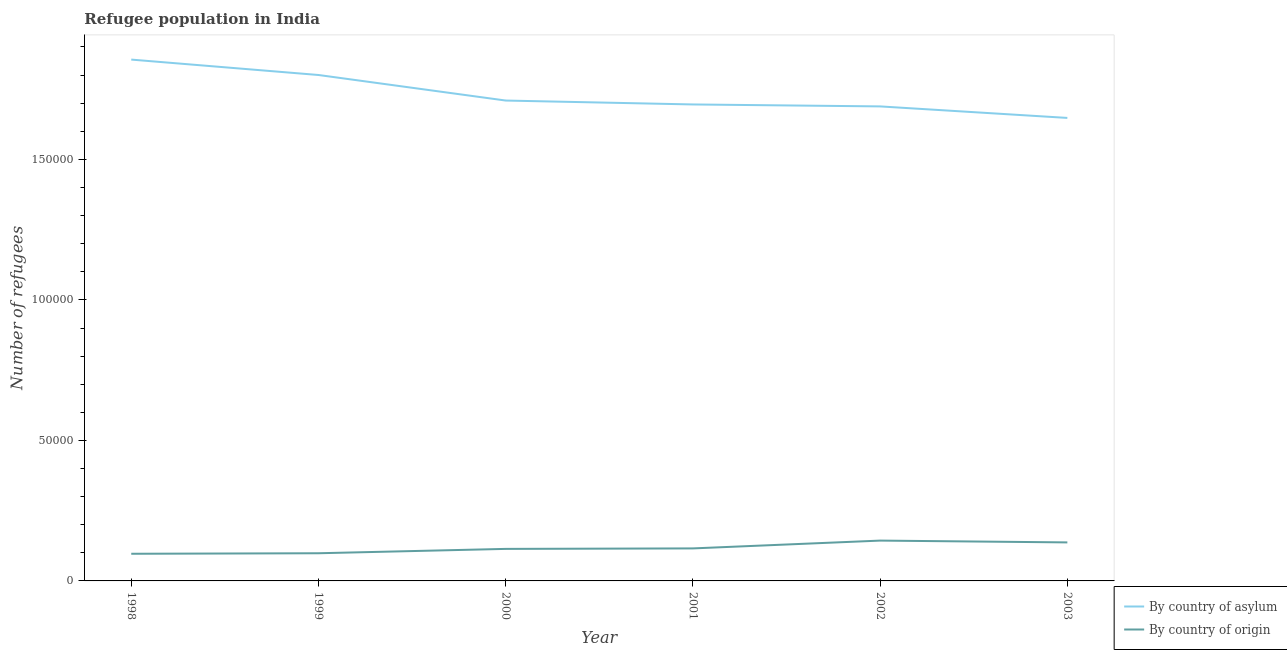Does the line corresponding to number of refugees by country of asylum intersect with the line corresponding to number of refugees by country of origin?
Offer a very short reply. No. Is the number of lines equal to the number of legend labels?
Your response must be concise. Yes. What is the number of refugees by country of origin in 2002?
Your answer should be compact. 1.43e+04. Across all years, what is the maximum number of refugees by country of origin?
Give a very brief answer. 1.43e+04. Across all years, what is the minimum number of refugees by country of origin?
Give a very brief answer. 9663. What is the total number of refugees by country of origin in the graph?
Keep it short and to the point. 7.05e+04. What is the difference between the number of refugees by country of origin in 1998 and that in 2003?
Your response must be concise. -4043. What is the difference between the number of refugees by country of origin in 2001 and the number of refugees by country of asylum in 2002?
Provide a succinct answer. -1.57e+05. What is the average number of refugees by country of asylum per year?
Your answer should be very brief. 1.73e+05. In the year 2003, what is the difference between the number of refugees by country of origin and number of refugees by country of asylum?
Keep it short and to the point. -1.51e+05. In how many years, is the number of refugees by country of origin greater than 80000?
Provide a succinct answer. 0. What is the ratio of the number of refugees by country of asylum in 1998 to that in 2000?
Offer a terse response. 1.09. Is the number of refugees by country of origin in 1998 less than that in 2001?
Provide a succinct answer. Yes. What is the difference between the highest and the second highest number of refugees by country of origin?
Your answer should be very brief. 643. What is the difference between the highest and the lowest number of refugees by country of origin?
Your response must be concise. 4686. Is the sum of the number of refugees by country of origin in 1998 and 2001 greater than the maximum number of refugees by country of asylum across all years?
Keep it short and to the point. No. Does the number of refugees by country of origin monotonically increase over the years?
Your response must be concise. No. Is the number of refugees by country of origin strictly greater than the number of refugees by country of asylum over the years?
Give a very brief answer. No. How many lines are there?
Provide a short and direct response. 2. How many years are there in the graph?
Make the answer very short. 6. What is the difference between two consecutive major ticks on the Y-axis?
Your response must be concise. 5.00e+04. Are the values on the major ticks of Y-axis written in scientific E-notation?
Your answer should be very brief. No. Does the graph contain any zero values?
Ensure brevity in your answer.  No. What is the title of the graph?
Keep it short and to the point. Refugee population in India. What is the label or title of the Y-axis?
Your response must be concise. Number of refugees. What is the Number of refugees of By country of asylum in 1998?
Your answer should be compact. 1.86e+05. What is the Number of refugees of By country of origin in 1998?
Your answer should be very brief. 9663. What is the Number of refugees in By country of asylum in 1999?
Your response must be concise. 1.80e+05. What is the Number of refugees of By country of origin in 1999?
Make the answer very short. 9845. What is the Number of refugees of By country of asylum in 2000?
Your answer should be very brief. 1.71e+05. What is the Number of refugees in By country of origin in 2000?
Ensure brevity in your answer.  1.14e+04. What is the Number of refugees in By country of asylum in 2001?
Your answer should be very brief. 1.70e+05. What is the Number of refugees of By country of origin in 2001?
Your response must be concise. 1.16e+04. What is the Number of refugees in By country of asylum in 2002?
Your response must be concise. 1.69e+05. What is the Number of refugees in By country of origin in 2002?
Provide a succinct answer. 1.43e+04. What is the Number of refugees of By country of asylum in 2003?
Ensure brevity in your answer.  1.65e+05. What is the Number of refugees in By country of origin in 2003?
Your answer should be compact. 1.37e+04. Across all years, what is the maximum Number of refugees of By country of asylum?
Your response must be concise. 1.86e+05. Across all years, what is the maximum Number of refugees of By country of origin?
Your answer should be very brief. 1.43e+04. Across all years, what is the minimum Number of refugees in By country of asylum?
Your answer should be compact. 1.65e+05. Across all years, what is the minimum Number of refugees of By country of origin?
Your response must be concise. 9663. What is the total Number of refugees in By country of asylum in the graph?
Your answer should be compact. 1.04e+06. What is the total Number of refugees in By country of origin in the graph?
Make the answer very short. 7.05e+04. What is the difference between the Number of refugees of By country of asylum in 1998 and that in 1999?
Ensure brevity in your answer.  5485. What is the difference between the Number of refugees in By country of origin in 1998 and that in 1999?
Make the answer very short. -182. What is the difference between the Number of refugees in By country of asylum in 1998 and that in 2000?
Your answer should be very brief. 1.46e+04. What is the difference between the Number of refugees of By country of origin in 1998 and that in 2000?
Offer a terse response. -1736. What is the difference between the Number of refugees of By country of asylum in 1998 and that in 2001?
Keep it short and to the point. 1.60e+04. What is the difference between the Number of refugees of By country of origin in 1998 and that in 2001?
Your answer should be compact. -1908. What is the difference between the Number of refugees of By country of asylum in 1998 and that in 2002?
Your answer should be compact. 1.67e+04. What is the difference between the Number of refugees in By country of origin in 1998 and that in 2002?
Ensure brevity in your answer.  -4686. What is the difference between the Number of refugees in By country of asylum in 1998 and that in 2003?
Keep it short and to the point. 2.08e+04. What is the difference between the Number of refugees of By country of origin in 1998 and that in 2003?
Keep it short and to the point. -4043. What is the difference between the Number of refugees of By country of asylum in 1999 and that in 2000?
Give a very brief answer. 9090. What is the difference between the Number of refugees in By country of origin in 1999 and that in 2000?
Offer a terse response. -1554. What is the difference between the Number of refugees in By country of asylum in 1999 and that in 2001?
Keep it short and to the point. 1.05e+04. What is the difference between the Number of refugees of By country of origin in 1999 and that in 2001?
Offer a very short reply. -1726. What is the difference between the Number of refugees of By country of asylum in 1999 and that in 2002?
Provide a succinct answer. 1.12e+04. What is the difference between the Number of refugees in By country of origin in 1999 and that in 2002?
Keep it short and to the point. -4504. What is the difference between the Number of refugees of By country of asylum in 1999 and that in 2003?
Provide a short and direct response. 1.53e+04. What is the difference between the Number of refugees of By country of origin in 1999 and that in 2003?
Offer a very short reply. -3861. What is the difference between the Number of refugees of By country of asylum in 2000 and that in 2001?
Offer a terse response. 1392. What is the difference between the Number of refugees of By country of origin in 2000 and that in 2001?
Provide a short and direct response. -172. What is the difference between the Number of refugees of By country of asylum in 2000 and that in 2002?
Your answer should be very brief. 2086. What is the difference between the Number of refugees in By country of origin in 2000 and that in 2002?
Offer a terse response. -2950. What is the difference between the Number of refugees in By country of asylum in 2000 and that in 2003?
Make the answer very short. 6184. What is the difference between the Number of refugees in By country of origin in 2000 and that in 2003?
Provide a short and direct response. -2307. What is the difference between the Number of refugees in By country of asylum in 2001 and that in 2002?
Keep it short and to the point. 694. What is the difference between the Number of refugees in By country of origin in 2001 and that in 2002?
Provide a succinct answer. -2778. What is the difference between the Number of refugees in By country of asylum in 2001 and that in 2003?
Ensure brevity in your answer.  4792. What is the difference between the Number of refugees in By country of origin in 2001 and that in 2003?
Your answer should be compact. -2135. What is the difference between the Number of refugees in By country of asylum in 2002 and that in 2003?
Ensure brevity in your answer.  4098. What is the difference between the Number of refugees of By country of origin in 2002 and that in 2003?
Keep it short and to the point. 643. What is the difference between the Number of refugees of By country of asylum in 1998 and the Number of refugees of By country of origin in 1999?
Make the answer very short. 1.76e+05. What is the difference between the Number of refugees of By country of asylum in 1998 and the Number of refugees of By country of origin in 2000?
Your answer should be very brief. 1.74e+05. What is the difference between the Number of refugees in By country of asylum in 1998 and the Number of refugees in By country of origin in 2001?
Make the answer very short. 1.74e+05. What is the difference between the Number of refugees in By country of asylum in 1998 and the Number of refugees in By country of origin in 2002?
Your response must be concise. 1.71e+05. What is the difference between the Number of refugees of By country of asylum in 1998 and the Number of refugees of By country of origin in 2003?
Provide a succinct answer. 1.72e+05. What is the difference between the Number of refugees of By country of asylum in 1999 and the Number of refugees of By country of origin in 2000?
Your answer should be very brief. 1.69e+05. What is the difference between the Number of refugees of By country of asylum in 1999 and the Number of refugees of By country of origin in 2001?
Offer a terse response. 1.68e+05. What is the difference between the Number of refugees in By country of asylum in 1999 and the Number of refugees in By country of origin in 2002?
Ensure brevity in your answer.  1.66e+05. What is the difference between the Number of refugees in By country of asylum in 1999 and the Number of refugees in By country of origin in 2003?
Your answer should be very brief. 1.66e+05. What is the difference between the Number of refugees in By country of asylum in 2000 and the Number of refugees in By country of origin in 2001?
Give a very brief answer. 1.59e+05. What is the difference between the Number of refugees in By country of asylum in 2000 and the Number of refugees in By country of origin in 2002?
Offer a very short reply. 1.57e+05. What is the difference between the Number of refugees in By country of asylum in 2000 and the Number of refugees in By country of origin in 2003?
Your answer should be compact. 1.57e+05. What is the difference between the Number of refugees of By country of asylum in 2001 and the Number of refugees of By country of origin in 2002?
Keep it short and to the point. 1.55e+05. What is the difference between the Number of refugees of By country of asylum in 2001 and the Number of refugees of By country of origin in 2003?
Your answer should be very brief. 1.56e+05. What is the difference between the Number of refugees of By country of asylum in 2002 and the Number of refugees of By country of origin in 2003?
Give a very brief answer. 1.55e+05. What is the average Number of refugees of By country of asylum per year?
Your response must be concise. 1.73e+05. What is the average Number of refugees in By country of origin per year?
Provide a succinct answer. 1.18e+04. In the year 1998, what is the difference between the Number of refugees of By country of asylum and Number of refugees of By country of origin?
Ensure brevity in your answer.  1.76e+05. In the year 1999, what is the difference between the Number of refugees in By country of asylum and Number of refugees in By country of origin?
Provide a succinct answer. 1.70e+05. In the year 2000, what is the difference between the Number of refugees in By country of asylum and Number of refugees in By country of origin?
Offer a terse response. 1.60e+05. In the year 2001, what is the difference between the Number of refugees of By country of asylum and Number of refugees of By country of origin?
Your answer should be very brief. 1.58e+05. In the year 2002, what is the difference between the Number of refugees of By country of asylum and Number of refugees of By country of origin?
Provide a short and direct response. 1.55e+05. In the year 2003, what is the difference between the Number of refugees of By country of asylum and Number of refugees of By country of origin?
Provide a succinct answer. 1.51e+05. What is the ratio of the Number of refugees of By country of asylum in 1998 to that in 1999?
Your answer should be very brief. 1.03. What is the ratio of the Number of refugees in By country of origin in 1998 to that in 1999?
Offer a very short reply. 0.98. What is the ratio of the Number of refugees of By country of asylum in 1998 to that in 2000?
Your response must be concise. 1.09. What is the ratio of the Number of refugees of By country of origin in 1998 to that in 2000?
Your answer should be very brief. 0.85. What is the ratio of the Number of refugees in By country of asylum in 1998 to that in 2001?
Keep it short and to the point. 1.09. What is the ratio of the Number of refugees in By country of origin in 1998 to that in 2001?
Provide a succinct answer. 0.84. What is the ratio of the Number of refugees of By country of asylum in 1998 to that in 2002?
Your answer should be compact. 1.1. What is the ratio of the Number of refugees of By country of origin in 1998 to that in 2002?
Your answer should be very brief. 0.67. What is the ratio of the Number of refugees in By country of asylum in 1998 to that in 2003?
Your response must be concise. 1.13. What is the ratio of the Number of refugees in By country of origin in 1998 to that in 2003?
Offer a terse response. 0.7. What is the ratio of the Number of refugees in By country of asylum in 1999 to that in 2000?
Give a very brief answer. 1.05. What is the ratio of the Number of refugees of By country of origin in 1999 to that in 2000?
Ensure brevity in your answer.  0.86. What is the ratio of the Number of refugees in By country of asylum in 1999 to that in 2001?
Offer a terse response. 1.06. What is the ratio of the Number of refugees of By country of origin in 1999 to that in 2001?
Your answer should be compact. 0.85. What is the ratio of the Number of refugees of By country of asylum in 1999 to that in 2002?
Your answer should be very brief. 1.07. What is the ratio of the Number of refugees of By country of origin in 1999 to that in 2002?
Provide a short and direct response. 0.69. What is the ratio of the Number of refugees in By country of asylum in 1999 to that in 2003?
Make the answer very short. 1.09. What is the ratio of the Number of refugees of By country of origin in 1999 to that in 2003?
Give a very brief answer. 0.72. What is the ratio of the Number of refugees in By country of asylum in 2000 to that in 2001?
Keep it short and to the point. 1.01. What is the ratio of the Number of refugees of By country of origin in 2000 to that in 2001?
Your answer should be compact. 0.99. What is the ratio of the Number of refugees of By country of asylum in 2000 to that in 2002?
Offer a very short reply. 1.01. What is the ratio of the Number of refugees in By country of origin in 2000 to that in 2002?
Keep it short and to the point. 0.79. What is the ratio of the Number of refugees in By country of asylum in 2000 to that in 2003?
Offer a very short reply. 1.04. What is the ratio of the Number of refugees of By country of origin in 2000 to that in 2003?
Provide a succinct answer. 0.83. What is the ratio of the Number of refugees of By country of asylum in 2001 to that in 2002?
Your answer should be compact. 1. What is the ratio of the Number of refugees in By country of origin in 2001 to that in 2002?
Provide a succinct answer. 0.81. What is the ratio of the Number of refugees of By country of asylum in 2001 to that in 2003?
Offer a very short reply. 1.03. What is the ratio of the Number of refugees in By country of origin in 2001 to that in 2003?
Make the answer very short. 0.84. What is the ratio of the Number of refugees of By country of asylum in 2002 to that in 2003?
Offer a very short reply. 1.02. What is the ratio of the Number of refugees of By country of origin in 2002 to that in 2003?
Offer a terse response. 1.05. What is the difference between the highest and the second highest Number of refugees of By country of asylum?
Ensure brevity in your answer.  5485. What is the difference between the highest and the second highest Number of refugees in By country of origin?
Your answer should be very brief. 643. What is the difference between the highest and the lowest Number of refugees in By country of asylum?
Offer a very short reply. 2.08e+04. What is the difference between the highest and the lowest Number of refugees in By country of origin?
Make the answer very short. 4686. 